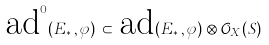Convert formula to latex. <formula><loc_0><loc_0><loc_500><loc_500>\text {ad} ^ { 0 } ( E _ { * } \, , \varphi ) \, \subset \, \text {ad} ( E _ { * } \, , \varphi ) \otimes { \mathcal { O } } _ { X } ( S )</formula> 